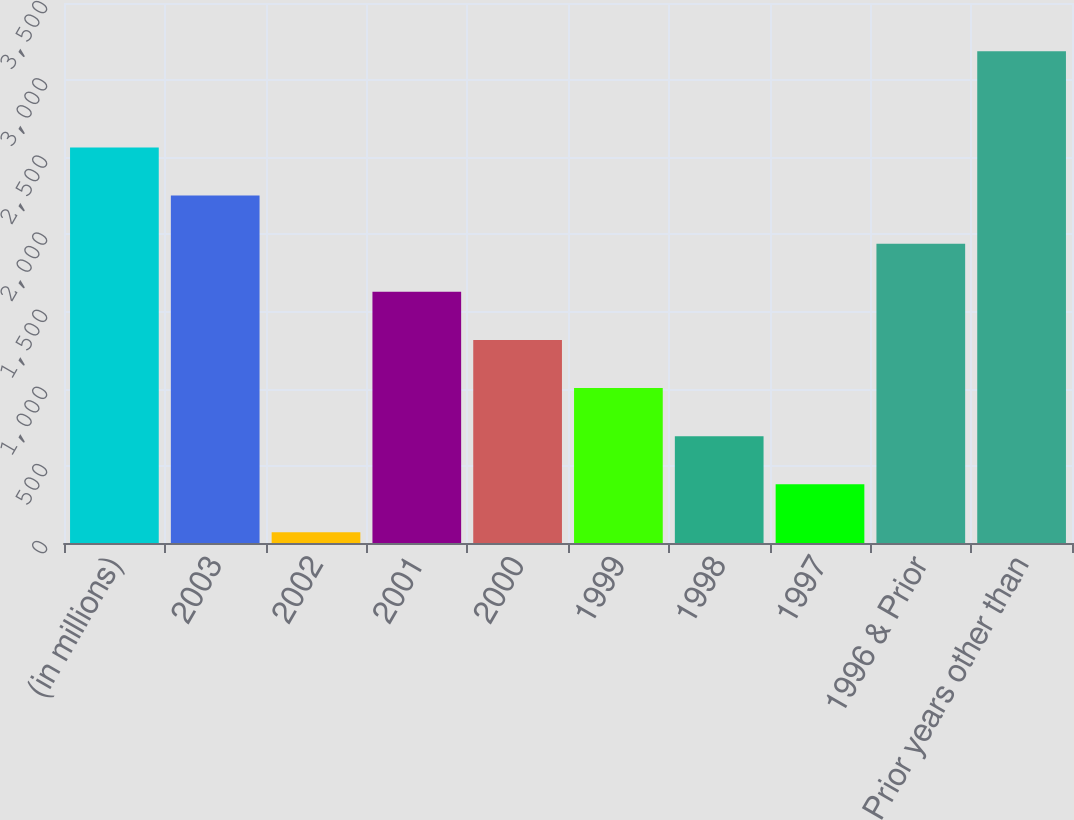Convert chart to OTSL. <chart><loc_0><loc_0><loc_500><loc_500><bar_chart><fcel>(in millions)<fcel>2003<fcel>2002<fcel>2001<fcel>2000<fcel>1999<fcel>1998<fcel>1997<fcel>1996 & Prior<fcel>Prior years other than<nl><fcel>2563.4<fcel>2251.6<fcel>69<fcel>1628<fcel>1316.2<fcel>1004.4<fcel>692.6<fcel>380.8<fcel>1939.8<fcel>3187<nl></chart> 